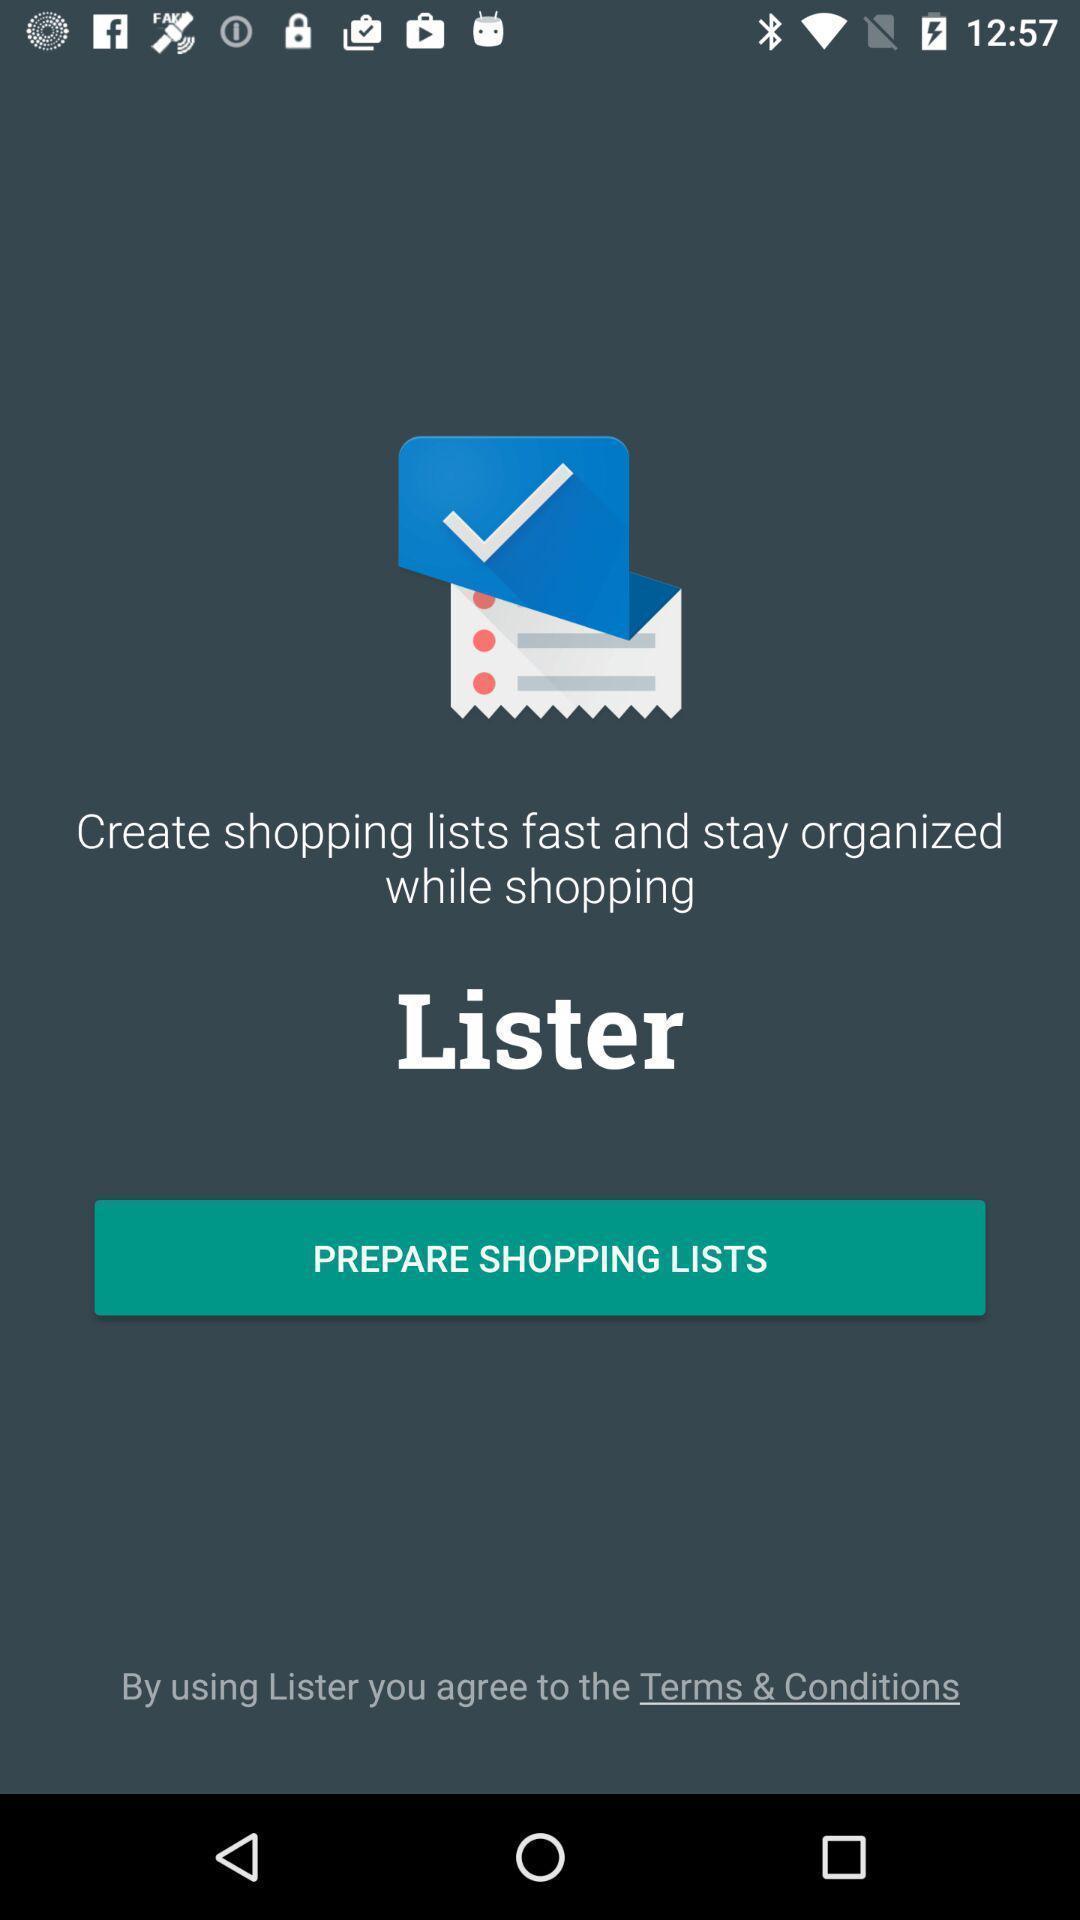Describe this image in words. Window displaying a page to create lists. 